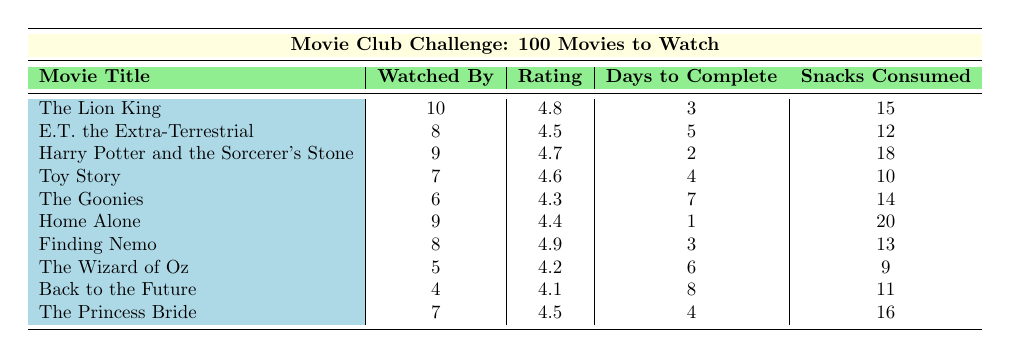What is the highest rating among the movies? The ratings are given for each movie: 4.8, 4.5, 4.7, 4.6, 4.3, 4.4, 4.9, 4.2, 4.1, and 4.5. The highest rating is 4.9, which corresponds to "Finding Nemo."
Answer: 4.9 How many members watched "The Goonies"? The table shows that "The Goonies" was watched by 6 members.
Answer: 6 What is the average number of snacks consumed across all movies? The total snacks consumed are: 15, 12, 18, 10, 14, 20, 13, 9, 11, and 16. Adding these gives 15 + 12 + 18 + 10 + 14 + 20 + 13 + 9 + 11 + 16 =  138. There are 10 movies, so the average is 138 / 10 = 13.8.
Answer: 13.8 Did "Home Alone" have the lowest days to complete? "Home Alone" took 1 day to complete. The other movies took 3, 5, 2, 4, 7, 3, 6, 8, and 4 days. Since 1 is the lowest, the statement is true.
Answer: Yes What movie had more members watching it: "Harry Potter and the Sorcerer's Stone" or "E.T. the Extra-Terrestrial"? "Harry Potter and the Sorcerer's Stone" was watched by 9 members, while "E.T. the Extra-Terrestrial" was watched by 8 members. Since 9 is greater than 8, the answer is "Harry Potter and the Sorcerer's Stone."
Answer: Harry Potter and the Sorcerer's Stone If the average rating of the top 3 movies was calculated, what would it be? The top 3 movies based on ratings are "Finding Nemo" (4.9), "Harry Potter and the Sorcerer's Stone" (4.7), and "The Lion King" (4.8). Adding the ratings gives 4.9 + 4.7 + 4.8 = 14.4. Dividing by 3 gives an average of 14.4 / 3 = 4.8.
Answer: 4.8 Which movie took the longest to complete? The table shows that the movie with the highest "Days to Complete" is "Back to the Future," with 8 days.
Answer: Back to the Future What is the total number of members who watched all the movies listed? The total number of members who watched the movies is calculated by adding the watched counts: 10 + 8 + 9 + 7 + 6 + 9 + 8 + 5 + 4 + 7 = 81.
Answer: 81 Are there more movies that took 3 days or more than 3 days to complete? The movies with 3 days or more are "E.T. the Extra-Terrestrial" (5), "Toy Story" (4), "The Goonies" (7), "Finding Nemo" (3), "The Wizard of Oz" (6), "Back to the Future" (8), and "The Princess Bride" (4), totaling 7 movies. The only movie that took less than 3 days is "Home Alone" (1) and "Harry Potter and the Sorcerer's Stone" (2), totaling 2 movies. Thus, there are more movies that took 3 days or more.
Answer: Yes Which movie consumes the most snacks? The snacks consumed for each movie are: 15, 12, 18, 10, 14, 20, 13, 9, 11, and 16. The highest number is 20, attributed to "Home Alone."
Answer: Home Alone 